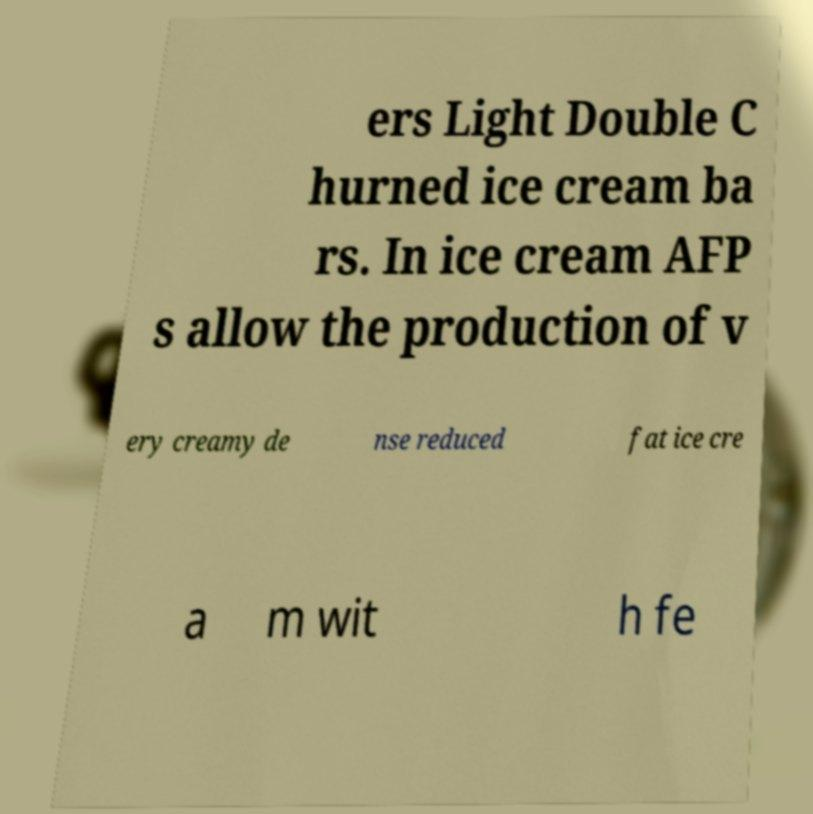Please identify and transcribe the text found in this image. ers Light Double C hurned ice cream ba rs. In ice cream AFP s allow the production of v ery creamy de nse reduced fat ice cre a m wit h fe 